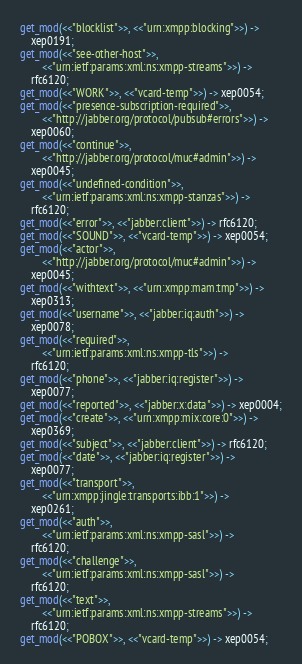Convert code to text. <code><loc_0><loc_0><loc_500><loc_500><_Erlang_>get_mod(<<"blocklist">>, <<"urn:xmpp:blocking">>) ->
    xep0191;
get_mod(<<"see-other-host">>,
        <<"urn:ietf:params:xml:ns:xmpp-streams">>) ->
    rfc6120;
get_mod(<<"WORK">>, <<"vcard-temp">>) -> xep0054;
get_mod(<<"presence-subscription-required">>,
        <<"http://jabber.org/protocol/pubsub#errors">>) ->
    xep0060;
get_mod(<<"continue">>,
        <<"http://jabber.org/protocol/muc#admin">>) ->
    xep0045;
get_mod(<<"undefined-condition">>,
        <<"urn:ietf:params:xml:ns:xmpp-stanzas">>) ->
    rfc6120;
get_mod(<<"error">>, <<"jabber:client">>) -> rfc6120;
get_mod(<<"SOUND">>, <<"vcard-temp">>) -> xep0054;
get_mod(<<"actor">>,
        <<"http://jabber.org/protocol/muc#admin">>) ->
    xep0045;
get_mod(<<"withtext">>, <<"urn:xmpp:mam:tmp">>) ->
    xep0313;
get_mod(<<"username">>, <<"jabber:iq:auth">>) ->
    xep0078;
get_mod(<<"required">>,
        <<"urn:ietf:params:xml:ns:xmpp-tls">>) ->
    rfc6120;
get_mod(<<"phone">>, <<"jabber:iq:register">>) ->
    xep0077;
get_mod(<<"reported">>, <<"jabber:x:data">>) -> xep0004;
get_mod(<<"create">>, <<"urn:xmpp:mix:core:0">>) ->
    xep0369;
get_mod(<<"subject">>, <<"jabber:client">>) -> rfc6120;
get_mod(<<"date">>, <<"jabber:iq:register">>) ->
    xep0077;
get_mod(<<"transport">>,
        <<"urn:xmpp:jingle:transports:ibb:1">>) ->
    xep0261;
get_mod(<<"auth">>,
        <<"urn:ietf:params:xml:ns:xmpp-sasl">>) ->
    rfc6120;
get_mod(<<"challenge">>,
        <<"urn:ietf:params:xml:ns:xmpp-sasl">>) ->
    rfc6120;
get_mod(<<"text">>,
        <<"urn:ietf:params:xml:ns:xmpp-streams">>) ->
    rfc6120;
get_mod(<<"POBOX">>, <<"vcard-temp">>) -> xep0054;</code> 